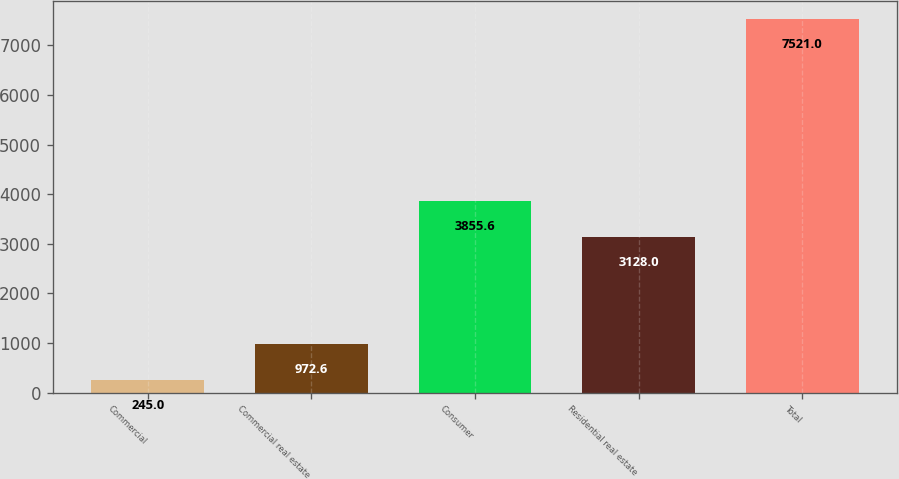Convert chart. <chart><loc_0><loc_0><loc_500><loc_500><bar_chart><fcel>Commercial<fcel>Commercial real estate<fcel>Consumer<fcel>Residential real estate<fcel>Total<nl><fcel>245<fcel>972.6<fcel>3855.6<fcel>3128<fcel>7521<nl></chart> 